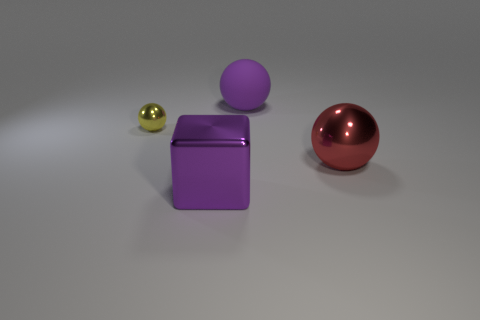Add 3 large purple matte objects. How many objects exist? 7 Subtract all spheres. How many objects are left? 1 Subtract 0 yellow blocks. How many objects are left? 4 Subtract all small yellow shiny balls. Subtract all large shiny balls. How many objects are left? 2 Add 3 big purple shiny things. How many big purple shiny things are left? 4 Add 1 yellow objects. How many yellow objects exist? 2 